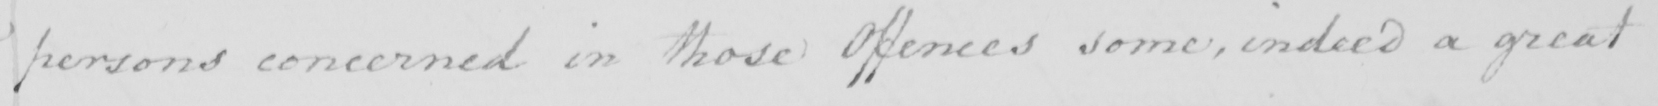Please provide the text content of this handwritten line. persons concerned in those Offences some , indeed a great 